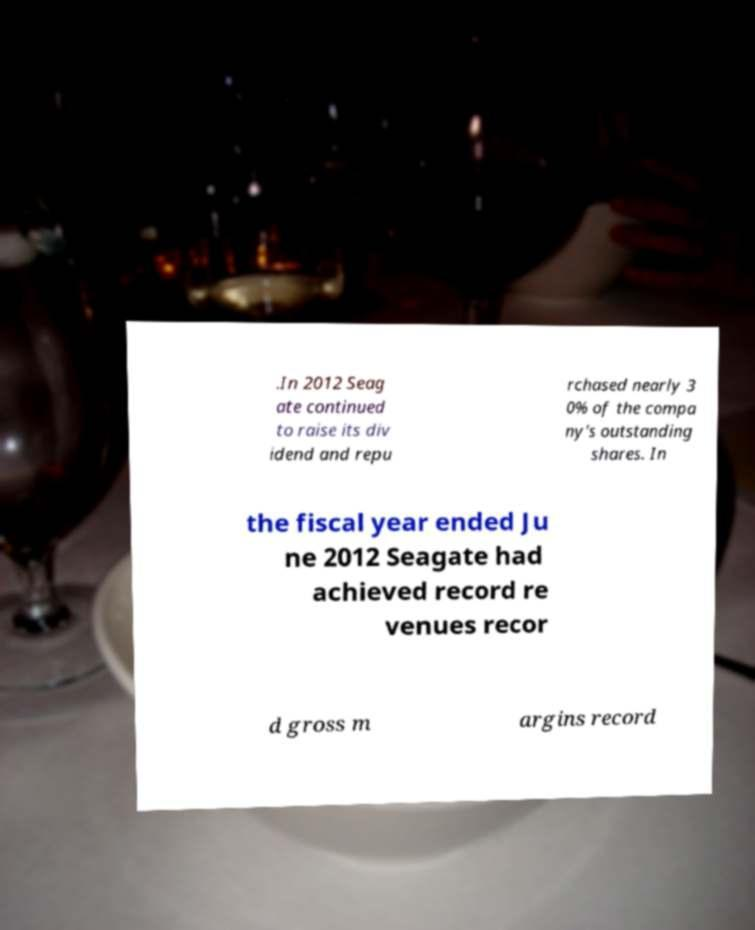For documentation purposes, I need the text within this image transcribed. Could you provide that? .In 2012 Seag ate continued to raise its div idend and repu rchased nearly 3 0% of the compa ny's outstanding shares. In the fiscal year ended Ju ne 2012 Seagate had achieved record re venues recor d gross m argins record 